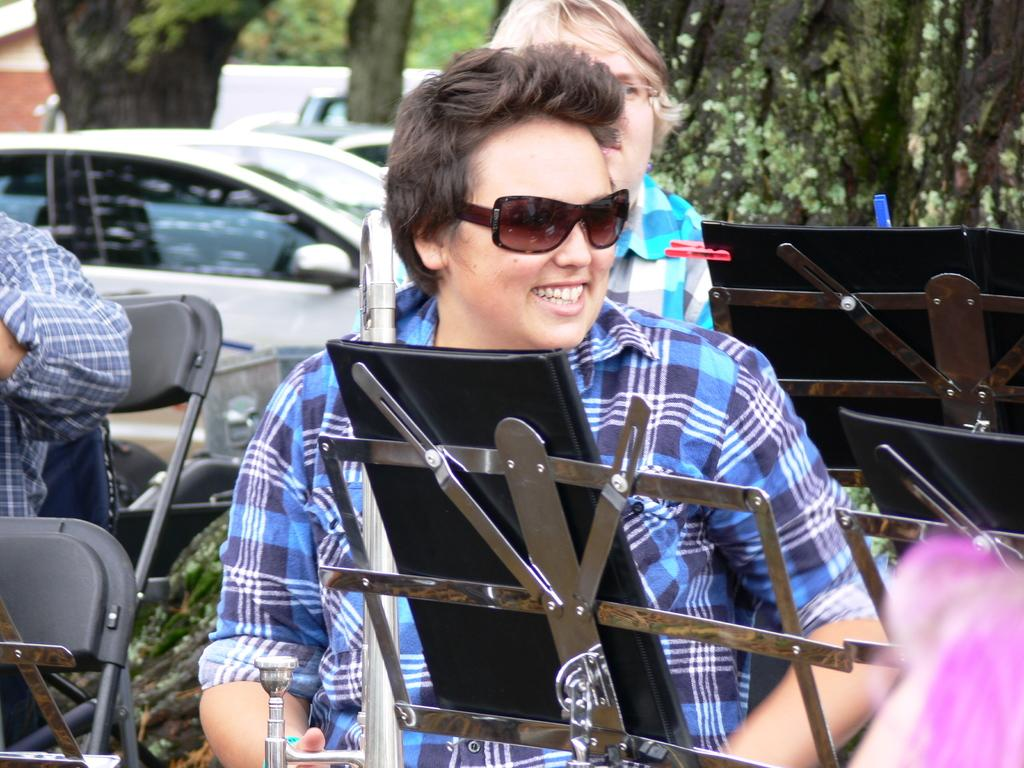What is present in the image? There is a person in the image. What is the person doing in the image? The person is sitting on a chair. What color is the ink on the person's face in the image? There is no ink or mention of ink on the person's face in the image. What part of the person's brain can be seen in the image? There is no part of the person's brain visible in the image. 